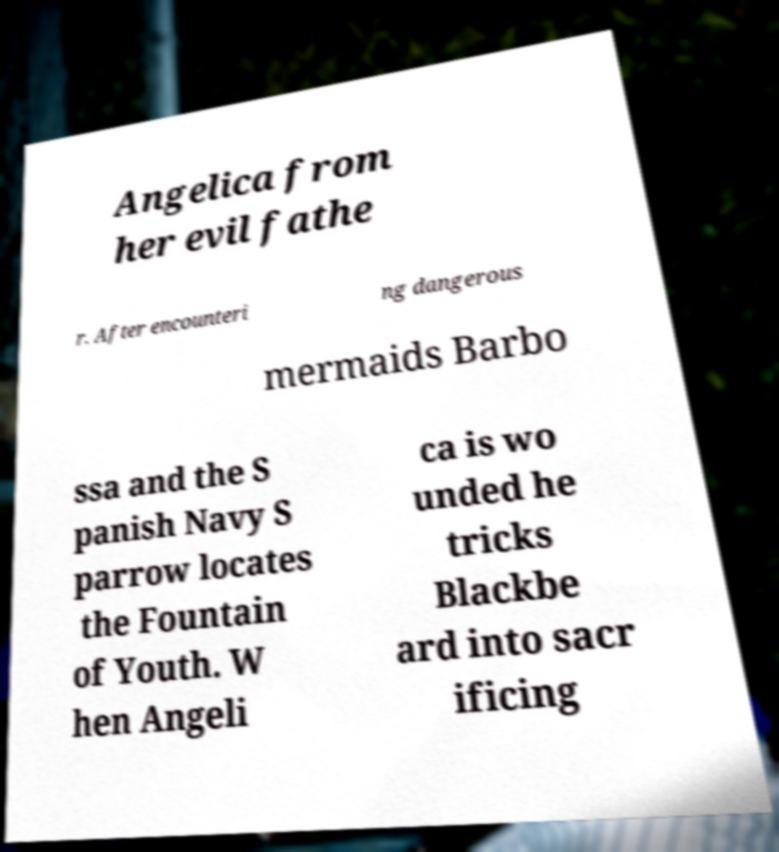Can you read and provide the text displayed in the image?This photo seems to have some interesting text. Can you extract and type it out for me? Angelica from her evil fathe r. After encounteri ng dangerous mermaids Barbo ssa and the S panish Navy S parrow locates the Fountain of Youth. W hen Angeli ca is wo unded he tricks Blackbe ard into sacr ificing 